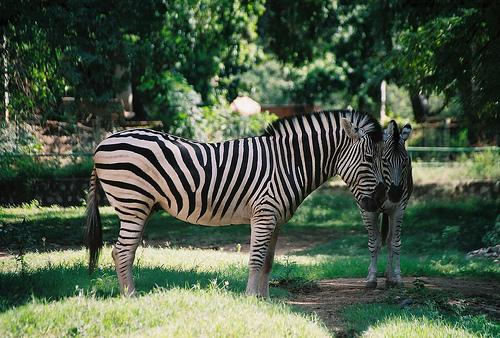Write an image caption with enough information to help someone with a visual impairment to picture it. Two zebras, one close and one farther away, are standing on grass spotted with sunlight and shade, surrounded by trees casting their branches over the scene, with their faces, black noses, and distinctive striped features visible. Write a simple, one-sentence description of the image. Two zebras with black and white stripes stand in a grassy area with sunlight and shade, and trees in the background. Compose a brief, story-like description of the image. Once upon a sunny day in a lush, green meadow, two zebras were standing side by side, basking in the warm sunlight as their black and white stripes shone beneath the dappled shade cast by the trees above. Explain the content of the image in the style of an art critic discussing a painting. The image presents two zebras in a sunlit natural setting that exemplifies the beauty and resilience of nature. The zebras' black and white stripes, along with the verdant grass and the contrasting light and shadows, form a harmonious visual symphony that captivates the viewer. Write a description of the image from the perspective of a wildlife photographer. In this beautiful photo, two zebras with striking black and white stripes are captured standing together in a sunlit grassy natural habitat, framed by the trees and shadows, showcasing their distinct features and the uniqueness of the environment. Imagine you are describing this image to a person who cannot see it. Provide as much detail as possible about the zebras and their surroundings. The image depicts two black and white striped zebras, one in the foreground and the other in the background, standing together in a bright sunny grassy area, with shadows scattered around. Their faces, ears, manes, tails, and legs are visible, and the trees stretch out behind them, casting branches that hang over the grass. Mention the primary elements in the image and their positions. Two zebras are standing together, one in the foreground and one in the background, with faces and black noses visible. There's a sunny spot and shade in the grassy area with trees in the background. Create a short, catchy headline for this image. "Sunny Stripes: Zebras Bask in Grassy Paradise" Briefly describe the main objects or subjects in the image and the overall atmosphere. The image features two zebras in a bright, sunny grassy area with shade and trees in the background, showcasing their beautiful black and white stripes. Provide a poetic description of the image. In a serene landscape, two charming zebras with black and white stripes stand gracefully, basking in the sunlight amidst a verdant grassy expanse, with gentle shadows from the trees above. 